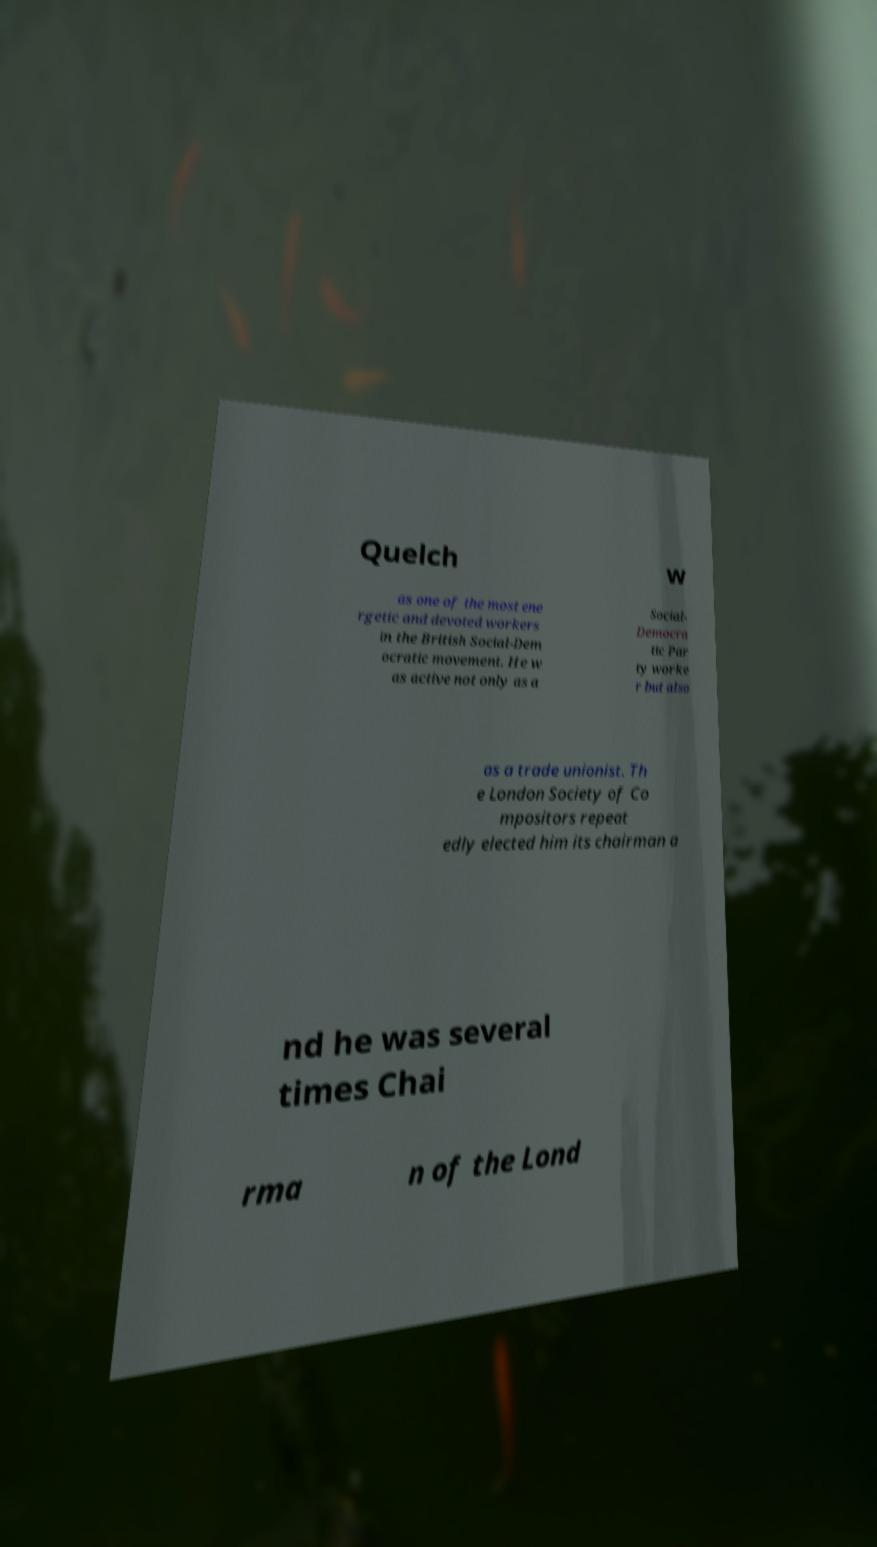Could you extract and type out the text from this image? Quelch w as one of the most ene rgetic and devoted workers in the British Social-Dem ocratic movement. He w as active not only as a Social- Democra tic Par ty worke r but also as a trade unionist. Th e London Society of Co mpositors repeat edly elected him its chairman a nd he was several times Chai rma n of the Lond 